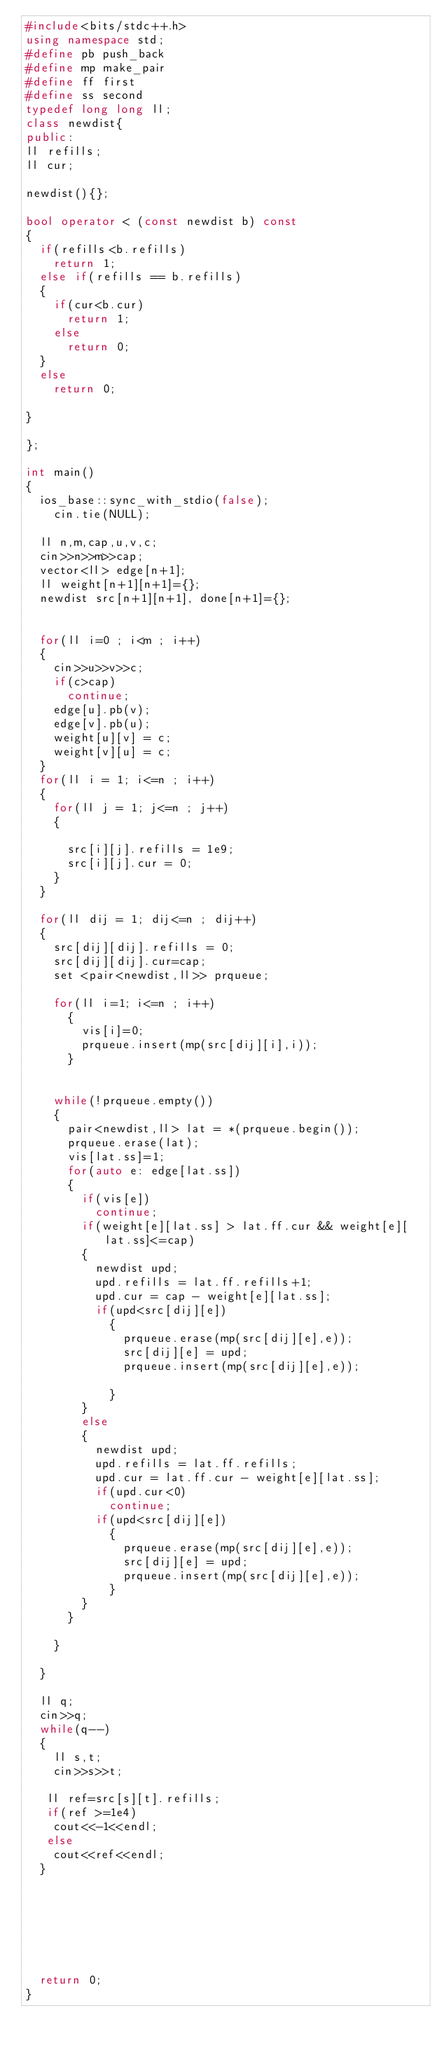<code> <loc_0><loc_0><loc_500><loc_500><_C++_>#include<bits/stdc++.h>
using namespace std;
#define pb push_back
#define mp make_pair
#define ff first
#define ss second
typedef long long ll;
class newdist{
public:
ll refills;
ll cur;

newdist(){};

bool operator < (const newdist b) const
{
	if(refills<b.refills)
		return 1;
	else if(refills == b.refills)
	{
		if(cur<b.cur)
			return 1;
		else
			return 0;
	}
	else
		return 0;

}

};

int main()
{
	ios_base::sync_with_stdio(false); 
    cin.tie(NULL);
	
	ll n,m,cap,u,v,c;
	cin>>n>>m>>cap;
	vector<ll> edge[n+1];
	ll weight[n+1][n+1]={};
	newdist src[n+1][n+1], done[n+1]={};
	
	
	for(ll i=0 ; i<m ; i++)
	{
		cin>>u>>v>>c;
		if(c>cap)
			continue;
		edge[u].pb(v);
		edge[v].pb(u);
		weight[u][v] = c;
		weight[v][u] = c;
	}
	for(ll i = 1; i<=n ; i++)
	{
		for(ll j = 1; j<=n ; j++)
		{
			
			src[i][j].refills = 1e9;
			src[i][j].cur = 0;
		}
	}

	for(ll dij = 1; dij<=n ; dij++)
	{
		src[dij][dij].refills = 0;
		src[dij][dij].cur=cap;
		set <pair<newdist,ll>> prqueue;
		
		for(ll i=1; i<=n ; i++)
			{
				vis[i]=0;
				prqueue.insert(mp(src[dij][i],i));
			}
				

		while(!prqueue.empty())
		{
			pair<newdist,ll> lat = *(prqueue.begin());
			prqueue.erase(lat);
			vis[lat.ss]=1;
			for(auto e: edge[lat.ss])
			{
				if(vis[e])
					continue;
				if(weight[e][lat.ss] > lat.ff.cur && weight[e][lat.ss]<=cap)
				{
					newdist upd;
					upd.refills = lat.ff.refills+1;
					upd.cur = cap - weight[e][lat.ss];
					if(upd<src[dij][e])
						{
							prqueue.erase(mp(src[dij][e],e));
							src[dij][e] = upd;
							prqueue.insert(mp(src[dij][e],e));
							
						}	
				}
				else
				{
					newdist upd;
					upd.refills = lat.ff.refills;
					upd.cur = lat.ff.cur - weight[e][lat.ss];
					if(upd.cur<0)
						continue;
					if(upd<src[dij][e])
						{
							prqueue.erase(mp(src[dij][e],e));
							src[dij][e] = upd;
							prqueue.insert(mp(src[dij][e],e));
						}	
				}
			}

		}

	}

	ll q;
	cin>>q;
	while(q--)
	{
		ll s,t;
		cin>>s>>t;

	 ll ref=src[s][t].refills;
	 if(ref >=1e4)
	 	cout<<-1<<endl;
	 else
	 	cout<<ref<<endl;
	}





	

	return 0;
}</code> 